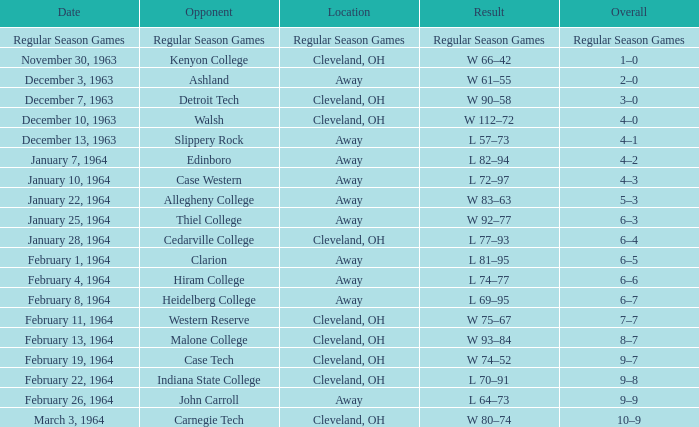What is the Date with an Opponent that is indiana state college? February 22, 1964. 